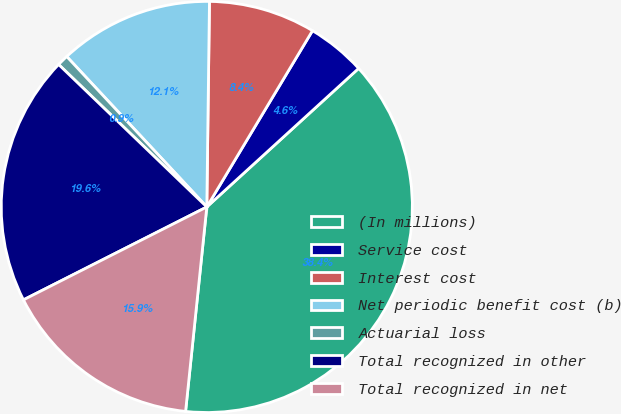Convert chart to OTSL. <chart><loc_0><loc_0><loc_500><loc_500><pie_chart><fcel>(In millions)<fcel>Service cost<fcel>Interest cost<fcel>Net periodic benefit cost (b)<fcel>Actuarial loss<fcel>Total recognized in other<fcel>Total recognized in net<nl><fcel>38.42%<fcel>4.63%<fcel>8.39%<fcel>12.14%<fcel>0.88%<fcel>19.65%<fcel>15.89%<nl></chart> 